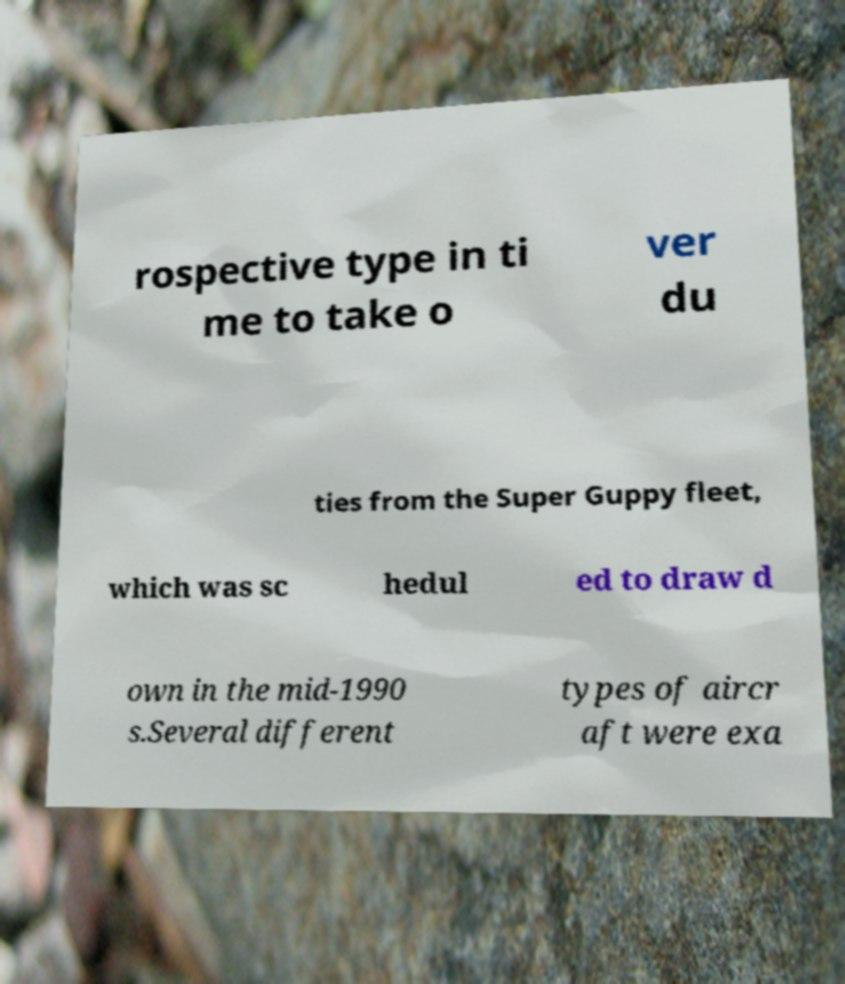Could you assist in decoding the text presented in this image and type it out clearly? rospective type in ti me to take o ver du ties from the Super Guppy fleet, which was sc hedul ed to draw d own in the mid-1990 s.Several different types of aircr aft were exa 